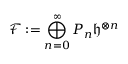<formula> <loc_0><loc_0><loc_500><loc_500>\mathcal { F } \colon = \bigoplus _ { n = 0 } ^ { \infty } P _ { n } \mathfrak { h } ^ { \otimes n }</formula> 